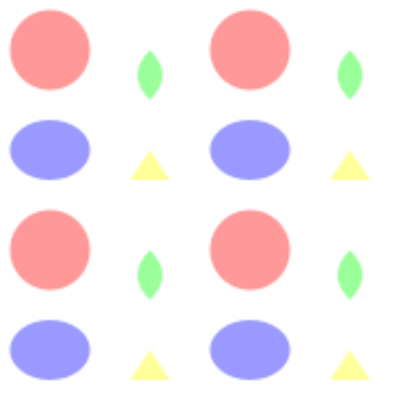In the tessellation above, how many complete fruit shapes are needed to create the repeating pattern unit? To determine the number of complete fruit shapes in the repeating pattern unit, we need to analyze the tessellation:

1. Observe the pattern: The tessellation is composed of various fruit shapes arranged in a grid.

2. Identify the shapes:
   - Circle (representing an apple or cherry)
   - Curved triangle (representing a pear or leaf)
   - Ellipse (representing a plum or grape)
   - Triangle (representing a strawberry)

3. Locate the repeating unit:
   - The pattern repeats horizontally and vertically every 200 units.
   - The repeating unit is a 2x2 grid of shapes.

4. Count the shapes in the repeating unit:
   - Top-left: 1 circle
   - Top-right: 1 curved triangle (pear/leaf)
   - Bottom-left: 1 ellipse (plum/grape)
   - Bottom-right: 1 triangle (strawberry)

5. Sum up the total number of shapes:
   1 + 1 + 1 + 1 = 4 complete fruit shapes

Therefore, the repeating pattern unit consists of 4 complete fruit shapes.
Answer: 4 